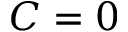<formula> <loc_0><loc_0><loc_500><loc_500>C = 0</formula> 